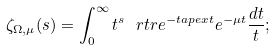Convert formula to latex. <formula><loc_0><loc_0><loc_500><loc_500>\zeta _ { \Omega , \mu } ( s ) = \int _ { 0 } ^ { \infty } t ^ { s } \ r t r e ^ { - t \L a p e x t } e ^ { - \mu t } \frac { d t } { t } ;</formula> 